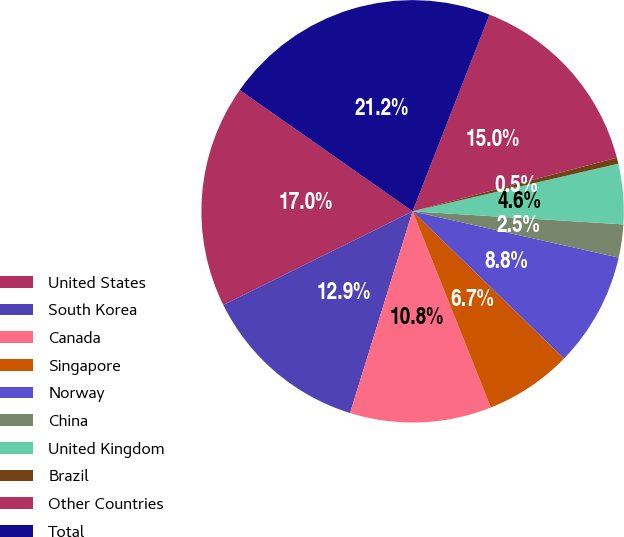<chart> <loc_0><loc_0><loc_500><loc_500><pie_chart><fcel>United States<fcel>South Korea<fcel>Canada<fcel>Singapore<fcel>Norway<fcel>China<fcel>United Kingdom<fcel>Brazil<fcel>Other Countries<fcel>Total<nl><fcel>17.05%<fcel>12.9%<fcel>10.83%<fcel>6.68%<fcel>8.76%<fcel>2.53%<fcel>4.61%<fcel>0.46%<fcel>14.98%<fcel>21.2%<nl></chart> 